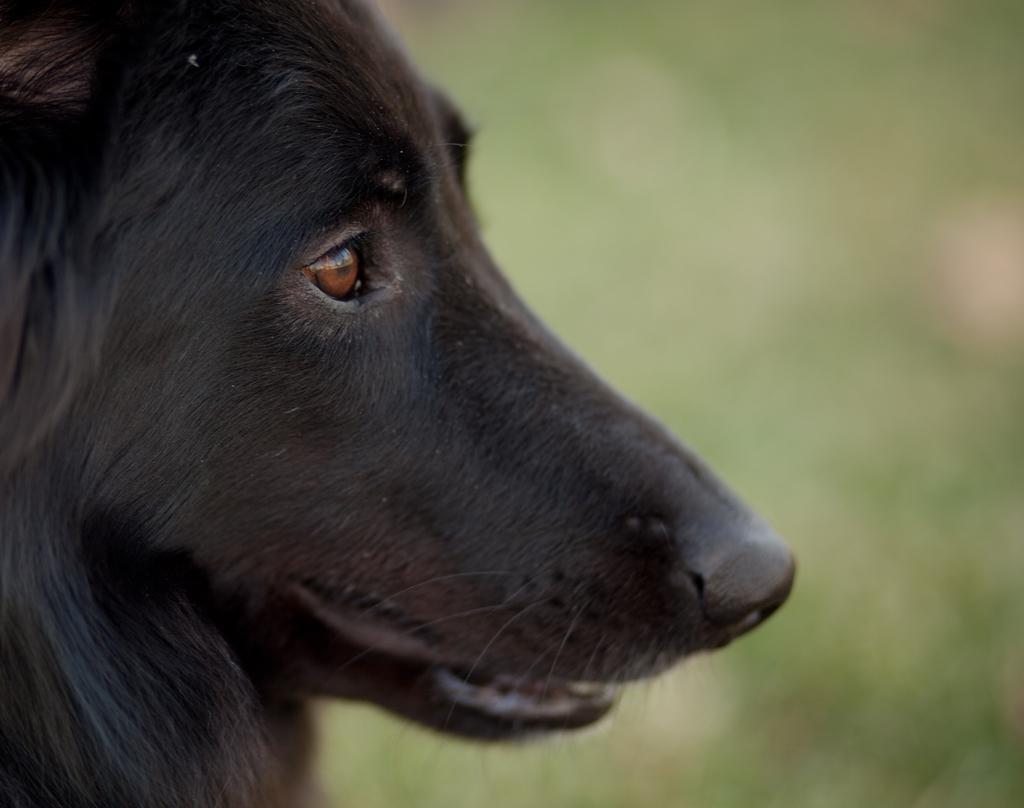Describe this image in one or two sentences. In the front of the image I can see a dog face. In the background of the image it is blurry. 